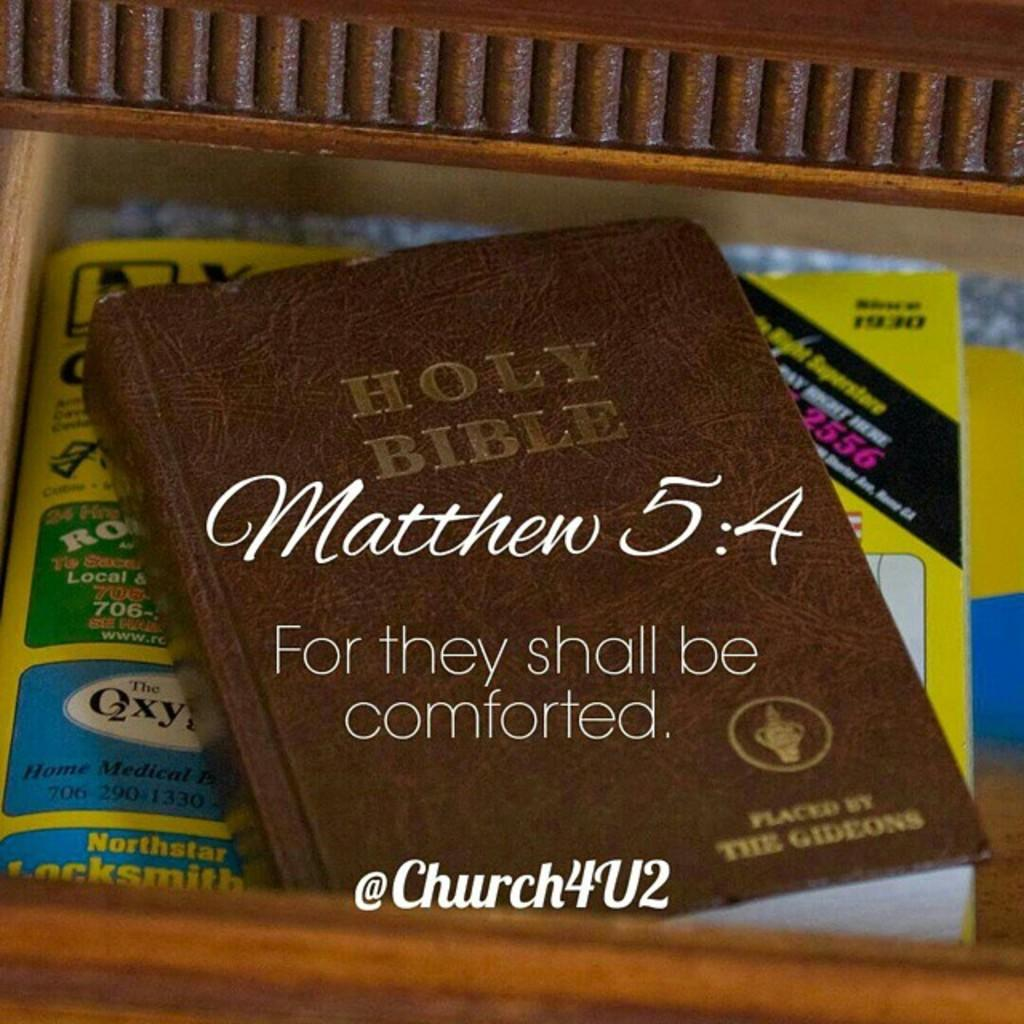Provide a one-sentence caption for the provided image. A brown Holy Bible with the words Matthew 5:4 written on the front. 